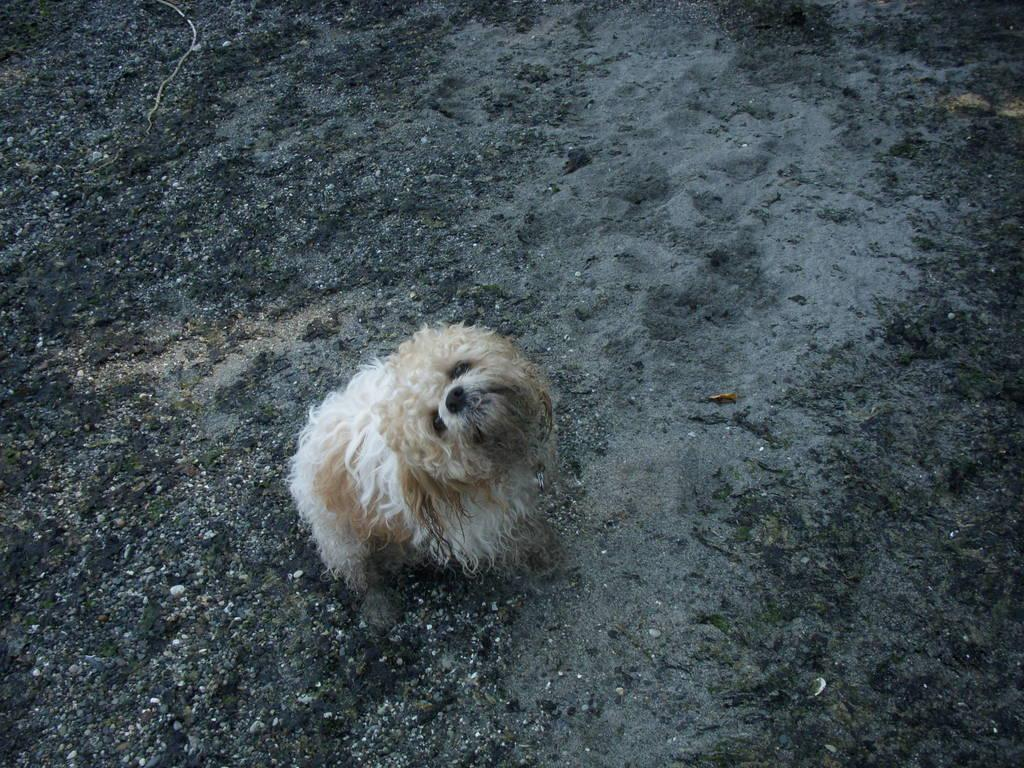What type of animal is present in the image? There is a dog in the image. Can you describe the position of the dog in the image? The dog is on the ground in the image. Where is the crate located in the image? There is no crate present in the image. What type of fruit is the dog holding in its neck in the image? There is no fruit or any object in the dog's neck in the image. 